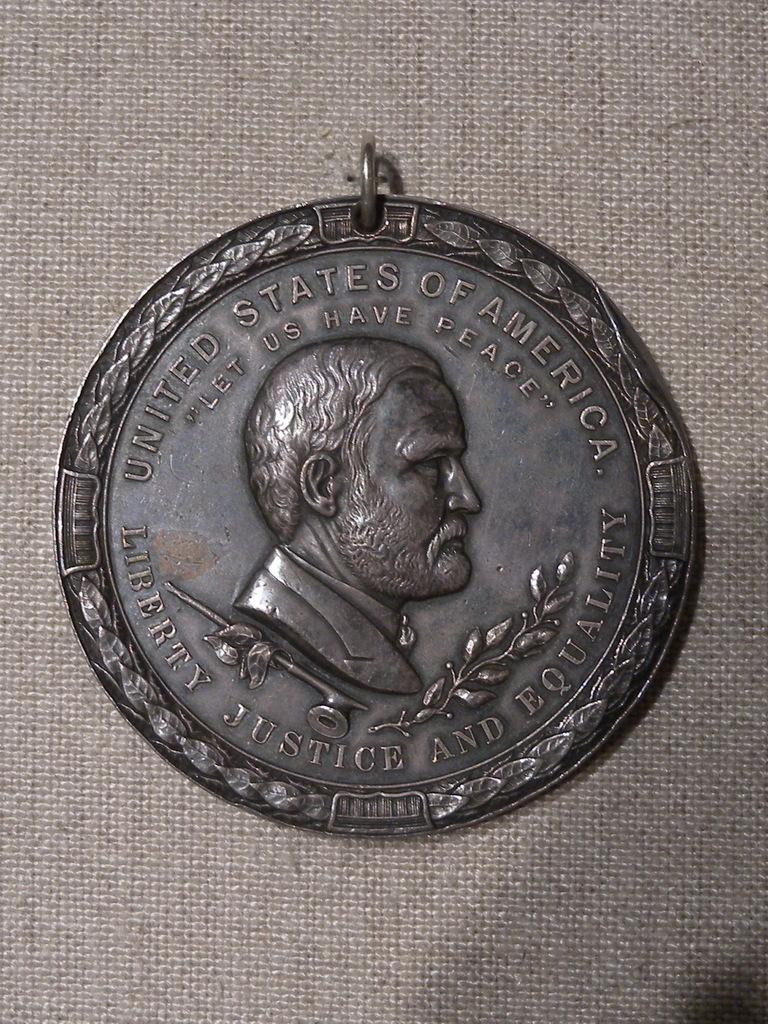What is the main object in the image? There is a coin in the image. What is the coin placed on? The coin is on a cloth. What material is the coin made of? The coin is made of metal. What can be seen on the surface of the coin? The coin has text and carvings on it. How does the comb help to style the fork in the image? There is no comb or fork present in the image; it only features a coin on a cloth. 